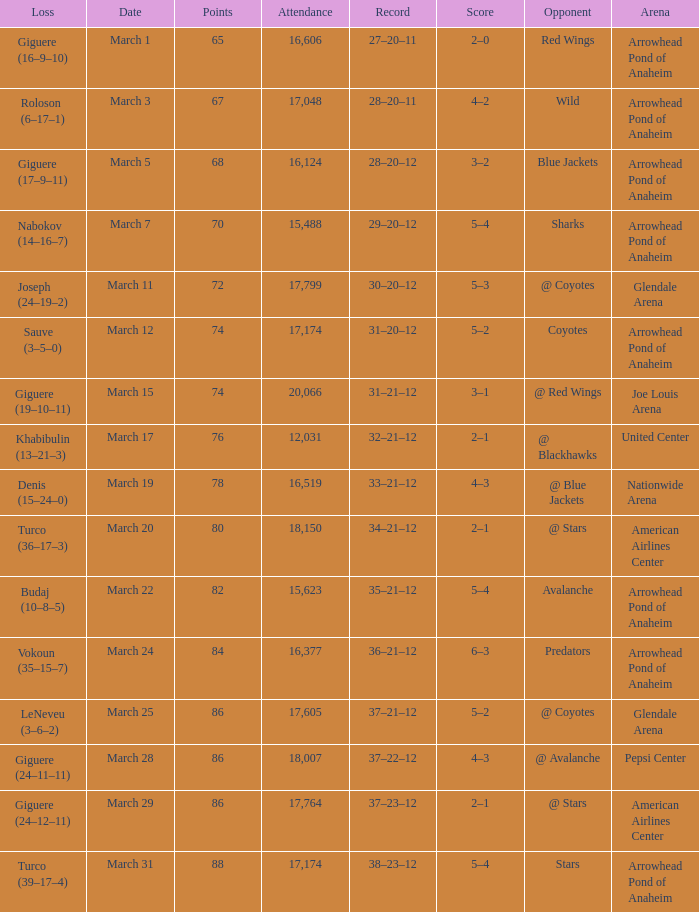What is the Record of the game with an Attendance of more than 16,124 and a Score of 6–3? 36–21–12. 